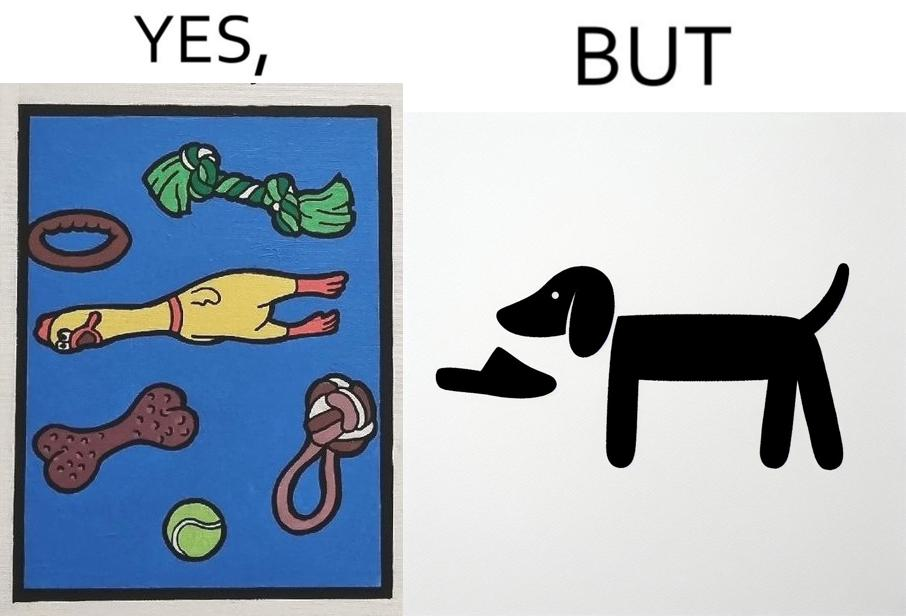What is shown in this image? the irony is that dog owners buy loads of toys for their dog but the dog's favourite toy is the owner's slippers 